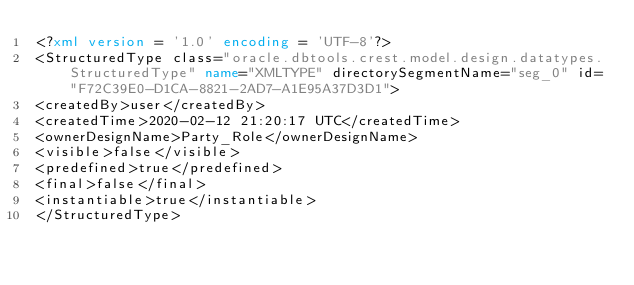<code> <loc_0><loc_0><loc_500><loc_500><_XML_><?xml version = '1.0' encoding = 'UTF-8'?>
<StructuredType class="oracle.dbtools.crest.model.design.datatypes.StructuredType" name="XMLTYPE" directorySegmentName="seg_0" id="F72C39E0-D1CA-8821-2AD7-A1E95A37D3D1">
<createdBy>user</createdBy>
<createdTime>2020-02-12 21:20:17 UTC</createdTime>
<ownerDesignName>Party_Role</ownerDesignName>
<visible>false</visible>
<predefined>true</predefined>
<final>false</final>
<instantiable>true</instantiable>
</StructuredType></code> 